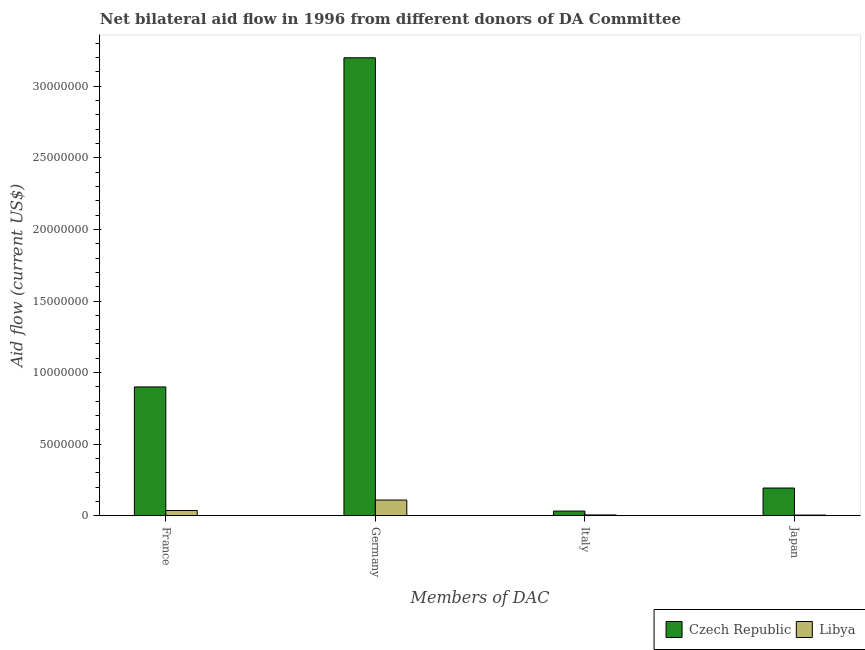How many different coloured bars are there?
Ensure brevity in your answer.  2. How many bars are there on the 1st tick from the right?
Provide a succinct answer. 2. What is the amount of aid given by japan in Libya?
Ensure brevity in your answer.  5.00e+04. Across all countries, what is the maximum amount of aid given by italy?
Ensure brevity in your answer.  3.30e+05. Across all countries, what is the minimum amount of aid given by japan?
Give a very brief answer. 5.00e+04. In which country was the amount of aid given by germany maximum?
Your response must be concise. Czech Republic. In which country was the amount of aid given by japan minimum?
Your answer should be very brief. Libya. What is the total amount of aid given by japan in the graph?
Give a very brief answer. 1.99e+06. What is the difference between the amount of aid given by japan in Libya and that in Czech Republic?
Your answer should be compact. -1.89e+06. What is the difference between the amount of aid given by france in Libya and the amount of aid given by japan in Czech Republic?
Give a very brief answer. -1.57e+06. What is the average amount of aid given by japan per country?
Your response must be concise. 9.95e+05. What is the difference between the amount of aid given by italy and amount of aid given by japan in Libya?
Offer a terse response. 10000. What is the ratio of the amount of aid given by germany in Libya to that in Czech Republic?
Ensure brevity in your answer.  0.03. Is the difference between the amount of aid given by japan in Libya and Czech Republic greater than the difference between the amount of aid given by france in Libya and Czech Republic?
Your answer should be very brief. Yes. What is the difference between the highest and the second highest amount of aid given by germany?
Ensure brevity in your answer.  3.09e+07. What is the difference between the highest and the lowest amount of aid given by germany?
Provide a short and direct response. 3.09e+07. Is the sum of the amount of aid given by france in Libya and Czech Republic greater than the maximum amount of aid given by italy across all countries?
Your answer should be very brief. Yes. What does the 2nd bar from the left in Italy represents?
Ensure brevity in your answer.  Libya. What does the 2nd bar from the right in Italy represents?
Offer a very short reply. Czech Republic. Is it the case that in every country, the sum of the amount of aid given by france and amount of aid given by germany is greater than the amount of aid given by italy?
Your answer should be compact. Yes. How many bars are there?
Ensure brevity in your answer.  8. Are the values on the major ticks of Y-axis written in scientific E-notation?
Offer a very short reply. No. Does the graph contain any zero values?
Make the answer very short. No. Does the graph contain grids?
Keep it short and to the point. No. How many legend labels are there?
Keep it short and to the point. 2. How are the legend labels stacked?
Provide a short and direct response. Horizontal. What is the title of the graph?
Offer a terse response. Net bilateral aid flow in 1996 from different donors of DA Committee. Does "Senegal" appear as one of the legend labels in the graph?
Your response must be concise. No. What is the label or title of the X-axis?
Offer a very short reply. Members of DAC. What is the Aid flow (current US$) of Czech Republic in France?
Your response must be concise. 9.00e+06. What is the Aid flow (current US$) of Czech Republic in Germany?
Provide a short and direct response. 3.20e+07. What is the Aid flow (current US$) in Libya in Germany?
Provide a succinct answer. 1.10e+06. What is the Aid flow (current US$) in Libya in Italy?
Give a very brief answer. 6.00e+04. What is the Aid flow (current US$) in Czech Republic in Japan?
Your response must be concise. 1.94e+06. What is the Aid flow (current US$) of Libya in Japan?
Ensure brevity in your answer.  5.00e+04. Across all Members of DAC, what is the maximum Aid flow (current US$) in Czech Republic?
Your response must be concise. 3.20e+07. Across all Members of DAC, what is the maximum Aid flow (current US$) in Libya?
Your answer should be compact. 1.10e+06. Across all Members of DAC, what is the minimum Aid flow (current US$) of Libya?
Offer a very short reply. 5.00e+04. What is the total Aid flow (current US$) in Czech Republic in the graph?
Keep it short and to the point. 4.33e+07. What is the total Aid flow (current US$) of Libya in the graph?
Keep it short and to the point. 1.58e+06. What is the difference between the Aid flow (current US$) in Czech Republic in France and that in Germany?
Make the answer very short. -2.30e+07. What is the difference between the Aid flow (current US$) in Libya in France and that in Germany?
Give a very brief answer. -7.30e+05. What is the difference between the Aid flow (current US$) in Czech Republic in France and that in Italy?
Make the answer very short. 8.67e+06. What is the difference between the Aid flow (current US$) of Czech Republic in France and that in Japan?
Your answer should be very brief. 7.06e+06. What is the difference between the Aid flow (current US$) of Czech Republic in Germany and that in Italy?
Your answer should be very brief. 3.17e+07. What is the difference between the Aid flow (current US$) of Libya in Germany and that in Italy?
Offer a terse response. 1.04e+06. What is the difference between the Aid flow (current US$) of Czech Republic in Germany and that in Japan?
Provide a succinct answer. 3.00e+07. What is the difference between the Aid flow (current US$) of Libya in Germany and that in Japan?
Offer a terse response. 1.05e+06. What is the difference between the Aid flow (current US$) of Czech Republic in Italy and that in Japan?
Provide a short and direct response. -1.61e+06. What is the difference between the Aid flow (current US$) of Libya in Italy and that in Japan?
Make the answer very short. 10000. What is the difference between the Aid flow (current US$) of Czech Republic in France and the Aid flow (current US$) of Libya in Germany?
Ensure brevity in your answer.  7.90e+06. What is the difference between the Aid flow (current US$) in Czech Republic in France and the Aid flow (current US$) in Libya in Italy?
Your answer should be compact. 8.94e+06. What is the difference between the Aid flow (current US$) in Czech Republic in France and the Aid flow (current US$) in Libya in Japan?
Provide a short and direct response. 8.95e+06. What is the difference between the Aid flow (current US$) in Czech Republic in Germany and the Aid flow (current US$) in Libya in Italy?
Offer a very short reply. 3.19e+07. What is the difference between the Aid flow (current US$) of Czech Republic in Germany and the Aid flow (current US$) of Libya in Japan?
Give a very brief answer. 3.19e+07. What is the average Aid flow (current US$) in Czech Republic per Members of DAC?
Offer a terse response. 1.08e+07. What is the average Aid flow (current US$) in Libya per Members of DAC?
Offer a very short reply. 3.95e+05. What is the difference between the Aid flow (current US$) of Czech Republic and Aid flow (current US$) of Libya in France?
Offer a terse response. 8.63e+06. What is the difference between the Aid flow (current US$) in Czech Republic and Aid flow (current US$) in Libya in Germany?
Your response must be concise. 3.09e+07. What is the difference between the Aid flow (current US$) of Czech Republic and Aid flow (current US$) of Libya in Italy?
Make the answer very short. 2.70e+05. What is the difference between the Aid flow (current US$) of Czech Republic and Aid flow (current US$) of Libya in Japan?
Ensure brevity in your answer.  1.89e+06. What is the ratio of the Aid flow (current US$) of Czech Republic in France to that in Germany?
Give a very brief answer. 0.28. What is the ratio of the Aid flow (current US$) in Libya in France to that in Germany?
Your answer should be compact. 0.34. What is the ratio of the Aid flow (current US$) of Czech Republic in France to that in Italy?
Offer a terse response. 27.27. What is the ratio of the Aid flow (current US$) in Libya in France to that in Italy?
Give a very brief answer. 6.17. What is the ratio of the Aid flow (current US$) in Czech Republic in France to that in Japan?
Your response must be concise. 4.64. What is the ratio of the Aid flow (current US$) in Libya in France to that in Japan?
Provide a succinct answer. 7.4. What is the ratio of the Aid flow (current US$) in Czech Republic in Germany to that in Italy?
Your answer should be very brief. 96.94. What is the ratio of the Aid flow (current US$) in Libya in Germany to that in Italy?
Make the answer very short. 18.33. What is the ratio of the Aid flow (current US$) of Czech Republic in Germany to that in Japan?
Keep it short and to the point. 16.49. What is the ratio of the Aid flow (current US$) of Libya in Germany to that in Japan?
Offer a very short reply. 22. What is the ratio of the Aid flow (current US$) of Czech Republic in Italy to that in Japan?
Your answer should be compact. 0.17. What is the difference between the highest and the second highest Aid flow (current US$) in Czech Republic?
Provide a short and direct response. 2.30e+07. What is the difference between the highest and the second highest Aid flow (current US$) in Libya?
Ensure brevity in your answer.  7.30e+05. What is the difference between the highest and the lowest Aid flow (current US$) of Czech Republic?
Provide a short and direct response. 3.17e+07. What is the difference between the highest and the lowest Aid flow (current US$) of Libya?
Provide a succinct answer. 1.05e+06. 